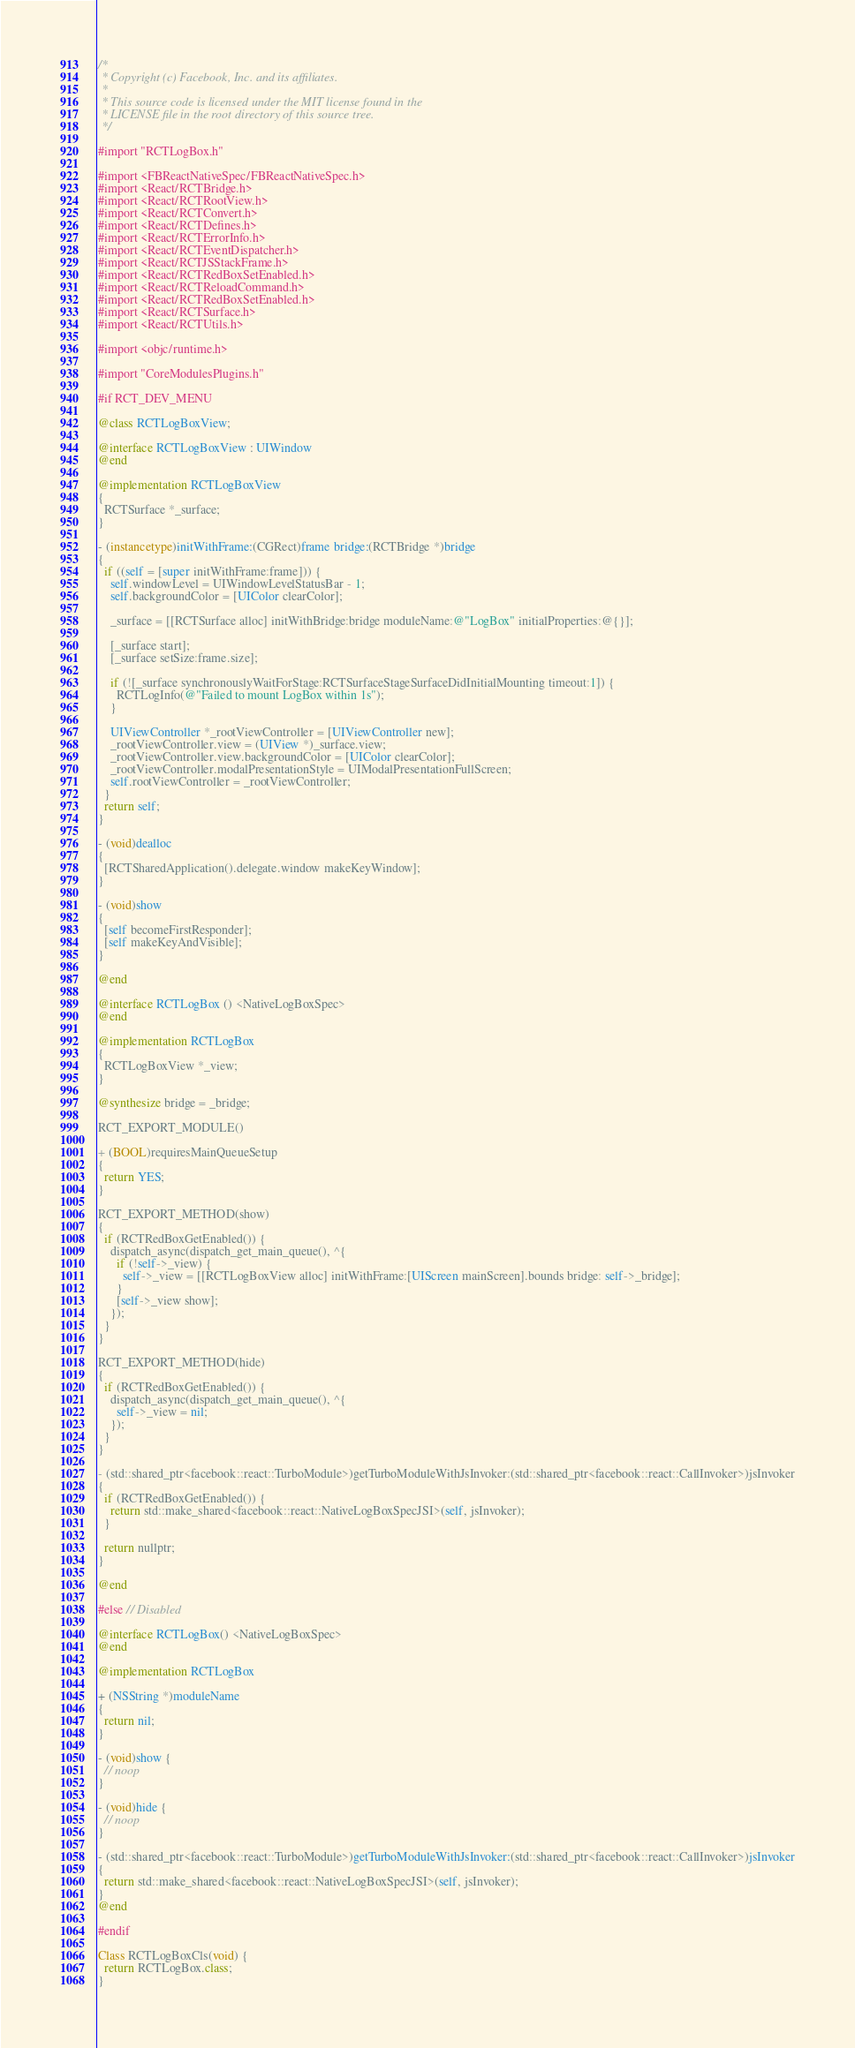<code> <loc_0><loc_0><loc_500><loc_500><_ObjectiveC_>/*
 * Copyright (c) Facebook, Inc. and its affiliates.
 *
 * This source code is licensed under the MIT license found in the
 * LICENSE file in the root directory of this source tree.
 */

#import "RCTLogBox.h"

#import <FBReactNativeSpec/FBReactNativeSpec.h>
#import <React/RCTBridge.h>
#import <React/RCTRootView.h>
#import <React/RCTConvert.h>
#import <React/RCTDefines.h>
#import <React/RCTErrorInfo.h>
#import <React/RCTEventDispatcher.h>
#import <React/RCTJSStackFrame.h>
#import <React/RCTRedBoxSetEnabled.h>
#import <React/RCTReloadCommand.h>
#import <React/RCTRedBoxSetEnabled.h>
#import <React/RCTSurface.h>
#import <React/RCTUtils.h>

#import <objc/runtime.h>

#import "CoreModulesPlugins.h"

#if RCT_DEV_MENU

@class RCTLogBoxView;

@interface RCTLogBoxView : UIWindow
@end

@implementation RCTLogBoxView
{
  RCTSurface *_surface;
}

- (instancetype)initWithFrame:(CGRect)frame bridge:(RCTBridge *)bridge
{
  if ((self = [super initWithFrame:frame])) {
    self.windowLevel = UIWindowLevelStatusBar - 1;
    self.backgroundColor = [UIColor clearColor];

    _surface = [[RCTSurface alloc] initWithBridge:bridge moduleName:@"LogBox" initialProperties:@{}];

    [_surface start];
    [_surface setSize:frame.size];

    if (![_surface synchronouslyWaitForStage:RCTSurfaceStageSurfaceDidInitialMounting timeout:1]) {
      RCTLogInfo(@"Failed to mount LogBox within 1s");
    }

    UIViewController *_rootViewController = [UIViewController new];
    _rootViewController.view = (UIView *)_surface.view;
    _rootViewController.view.backgroundColor = [UIColor clearColor];
    _rootViewController.modalPresentationStyle = UIModalPresentationFullScreen;
    self.rootViewController = _rootViewController;
  }
  return self;
}

- (void)dealloc
{
  [RCTSharedApplication().delegate.window makeKeyWindow];
}

- (void)show
{
  [self becomeFirstResponder];
  [self makeKeyAndVisible];
}

@end

@interface RCTLogBox () <NativeLogBoxSpec>
@end

@implementation RCTLogBox
{
  RCTLogBoxView *_view;
}

@synthesize bridge = _bridge;

RCT_EXPORT_MODULE()

+ (BOOL)requiresMainQueueSetup
{
  return YES;
}

RCT_EXPORT_METHOD(show)
{
  if (RCTRedBoxGetEnabled()) {
    dispatch_async(dispatch_get_main_queue(), ^{
      if (!self->_view) {
        self->_view = [[RCTLogBoxView alloc] initWithFrame:[UIScreen mainScreen].bounds bridge: self->_bridge];
      }
      [self->_view show];
    });
  }
}

RCT_EXPORT_METHOD(hide)
{
  if (RCTRedBoxGetEnabled()) {
    dispatch_async(dispatch_get_main_queue(), ^{
      self->_view = nil;
    });
  }
}

- (std::shared_ptr<facebook::react::TurboModule>)getTurboModuleWithJsInvoker:(std::shared_ptr<facebook::react::CallInvoker>)jsInvoker
{
  if (RCTRedBoxGetEnabled()) {
    return std::make_shared<facebook::react::NativeLogBoxSpecJSI>(self, jsInvoker);
  }

  return nullptr;
}

@end

#else // Disabled

@interface RCTLogBox() <NativeLogBoxSpec>
@end

@implementation RCTLogBox

+ (NSString *)moduleName
{
  return nil;
}

- (void)show {
  // noop
}

- (void)hide {
  // noop
}

- (std::shared_ptr<facebook::react::TurboModule>)getTurboModuleWithJsInvoker:(std::shared_ptr<facebook::react::CallInvoker>)jsInvoker
{
  return std::make_shared<facebook::react::NativeLogBoxSpecJSI>(self, jsInvoker);
}
@end

#endif

Class RCTLogBoxCls(void) {
  return RCTLogBox.class;
}
</code> 